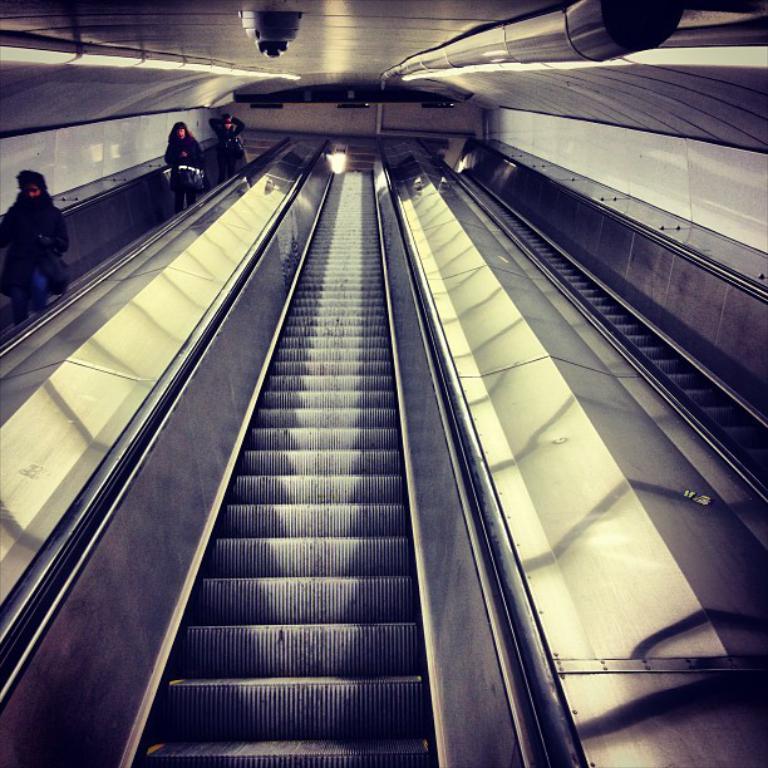How would you summarize this image in a sentence or two? In this picture we can see few people on the escalator, and also we can find lights. 